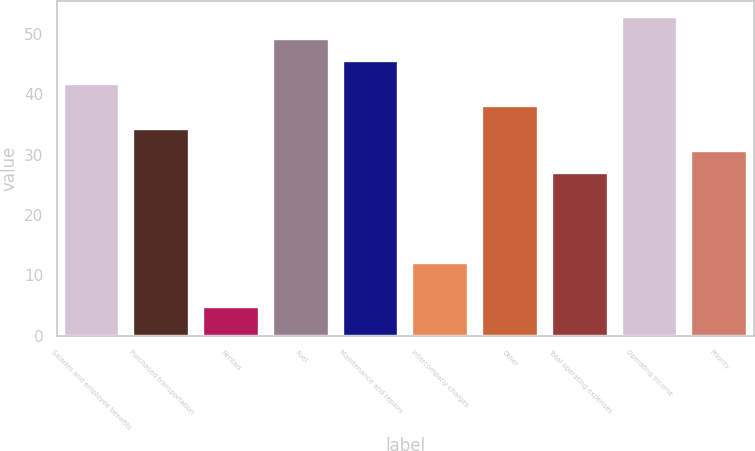Convert chart to OTSL. <chart><loc_0><loc_0><loc_500><loc_500><bar_chart><fcel>Salaries and employee benefits<fcel>Purchased transportation<fcel>Rentals<fcel>Fuel<fcel>Maintenance and repairs<fcel>Intercompany charges<fcel>Other<fcel>Total operating expenses<fcel>Operating income<fcel>Priority<nl><fcel>41.7<fcel>34.3<fcel>4.7<fcel>49.1<fcel>45.4<fcel>12.1<fcel>38<fcel>26.9<fcel>52.8<fcel>30.6<nl></chart> 